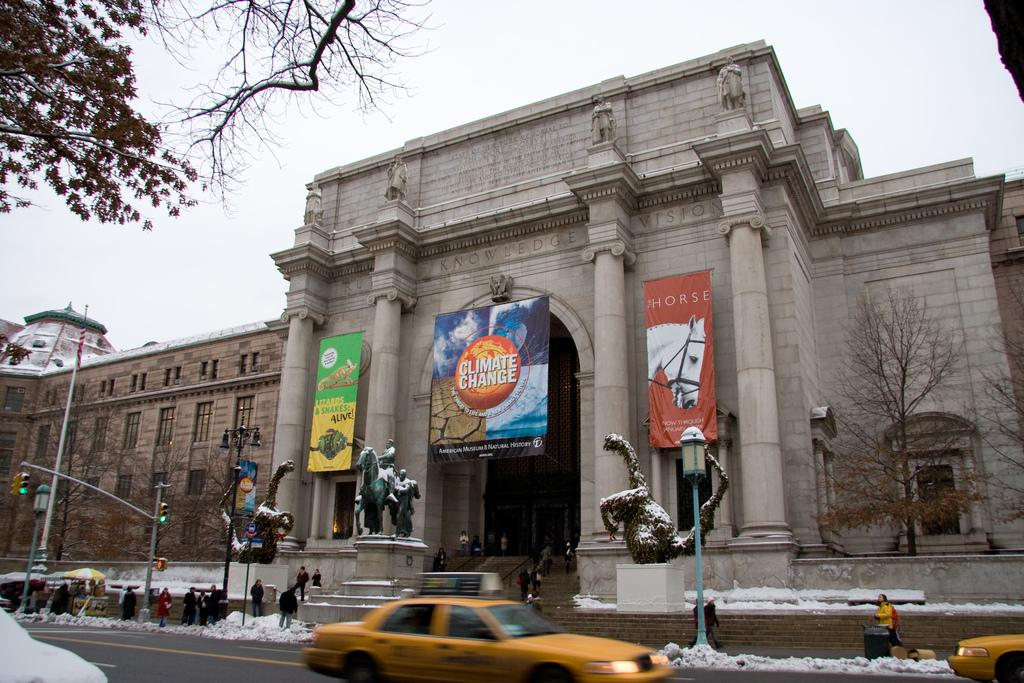<image>
Offer a succinct explanation of the picture presented. A banner for climate change hangs in front of a large building. 